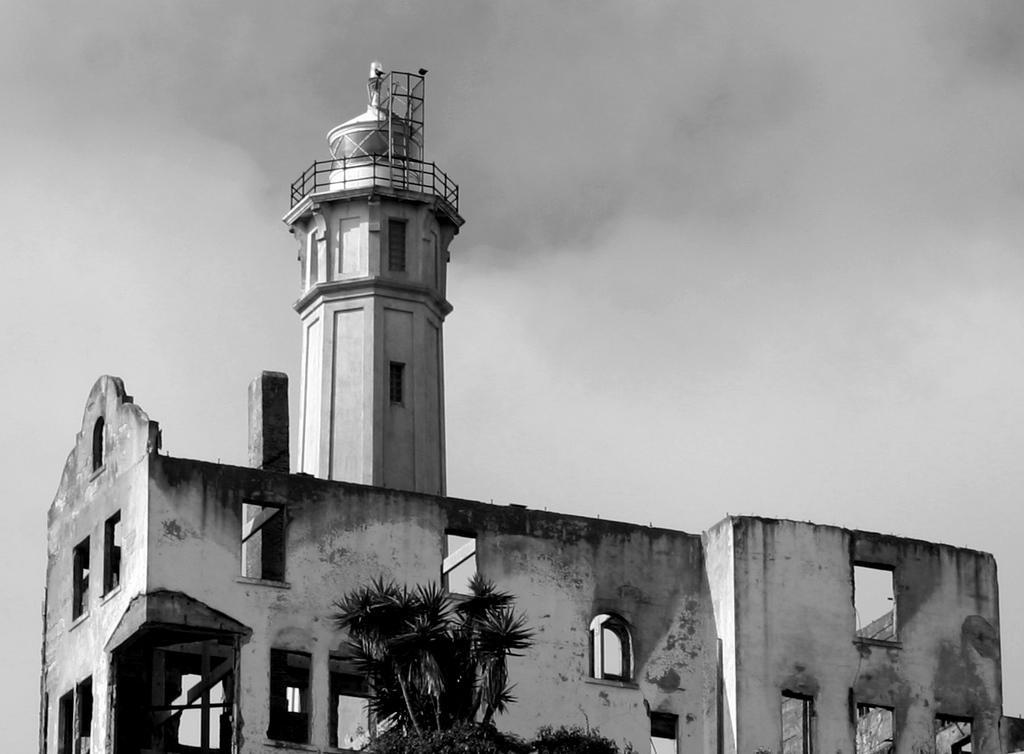In one or two sentences, can you explain what this image depicts? In the center of the image there is a tower. At the bottom we can see a tree. In the background there is sky. 